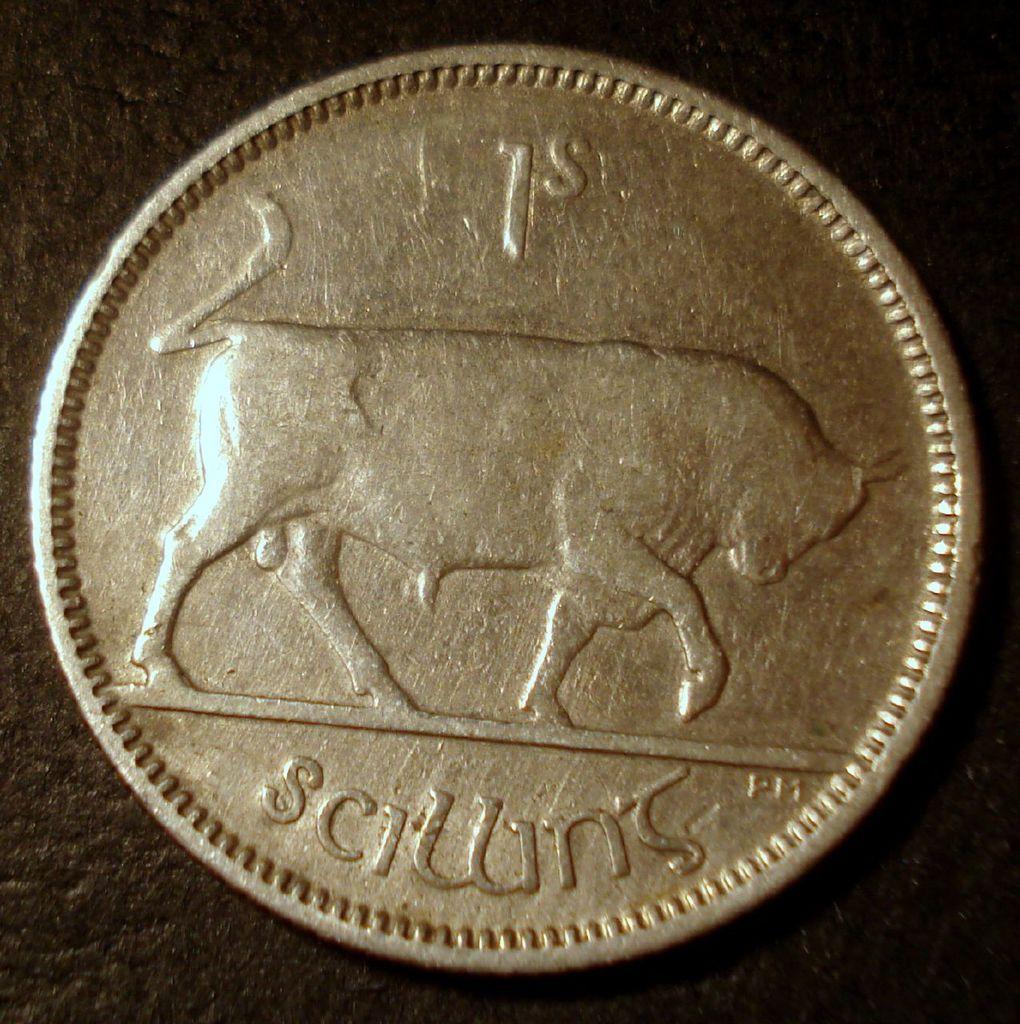What is below the bull?
Provide a short and direct response. Unanswerable. What is written directly above the bull?
Keep it short and to the point. 1s. 